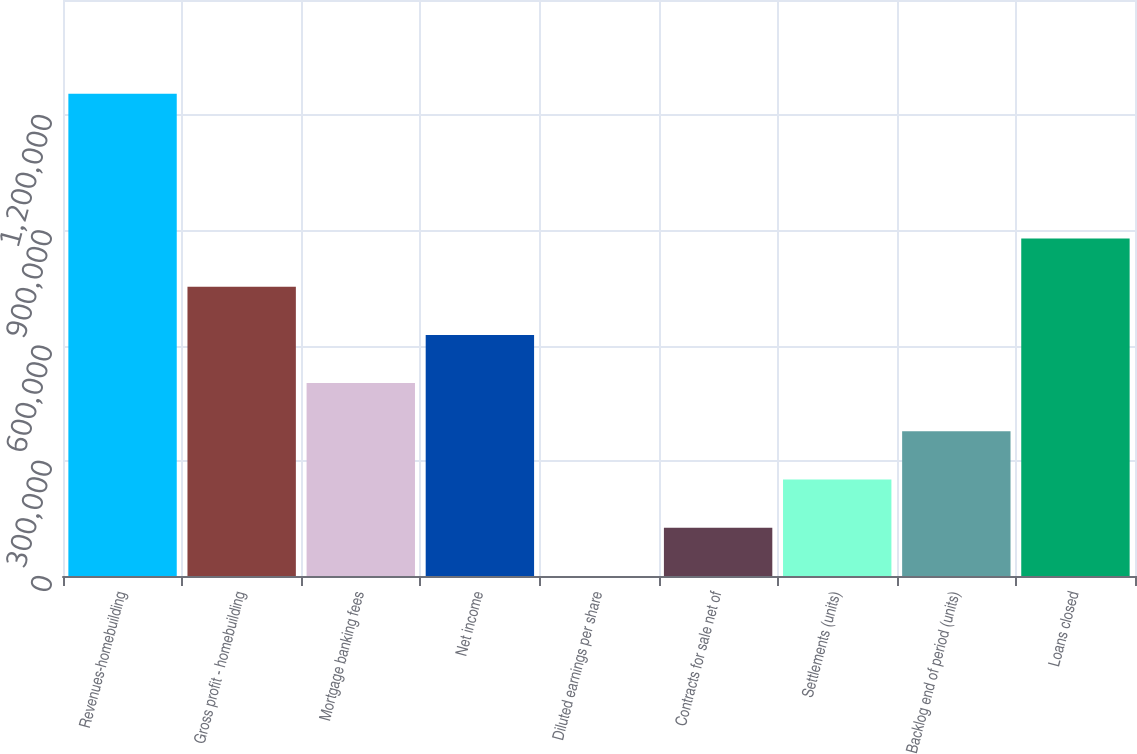Convert chart. <chart><loc_0><loc_0><loc_500><loc_500><bar_chart><fcel>Revenues-homebuilding<fcel>Gross profit - homebuilding<fcel>Mortgage banking fees<fcel>Net income<fcel>Diluted earnings per share<fcel>Contracts for sale net of<fcel>Settlements (units)<fcel>Backlog end of period (units)<fcel>Loans closed<nl><fcel>1.25571e+06<fcel>753436<fcel>502298<fcel>627867<fcel>20.13<fcel>125590<fcel>251159<fcel>376728<fcel>879006<nl></chart> 